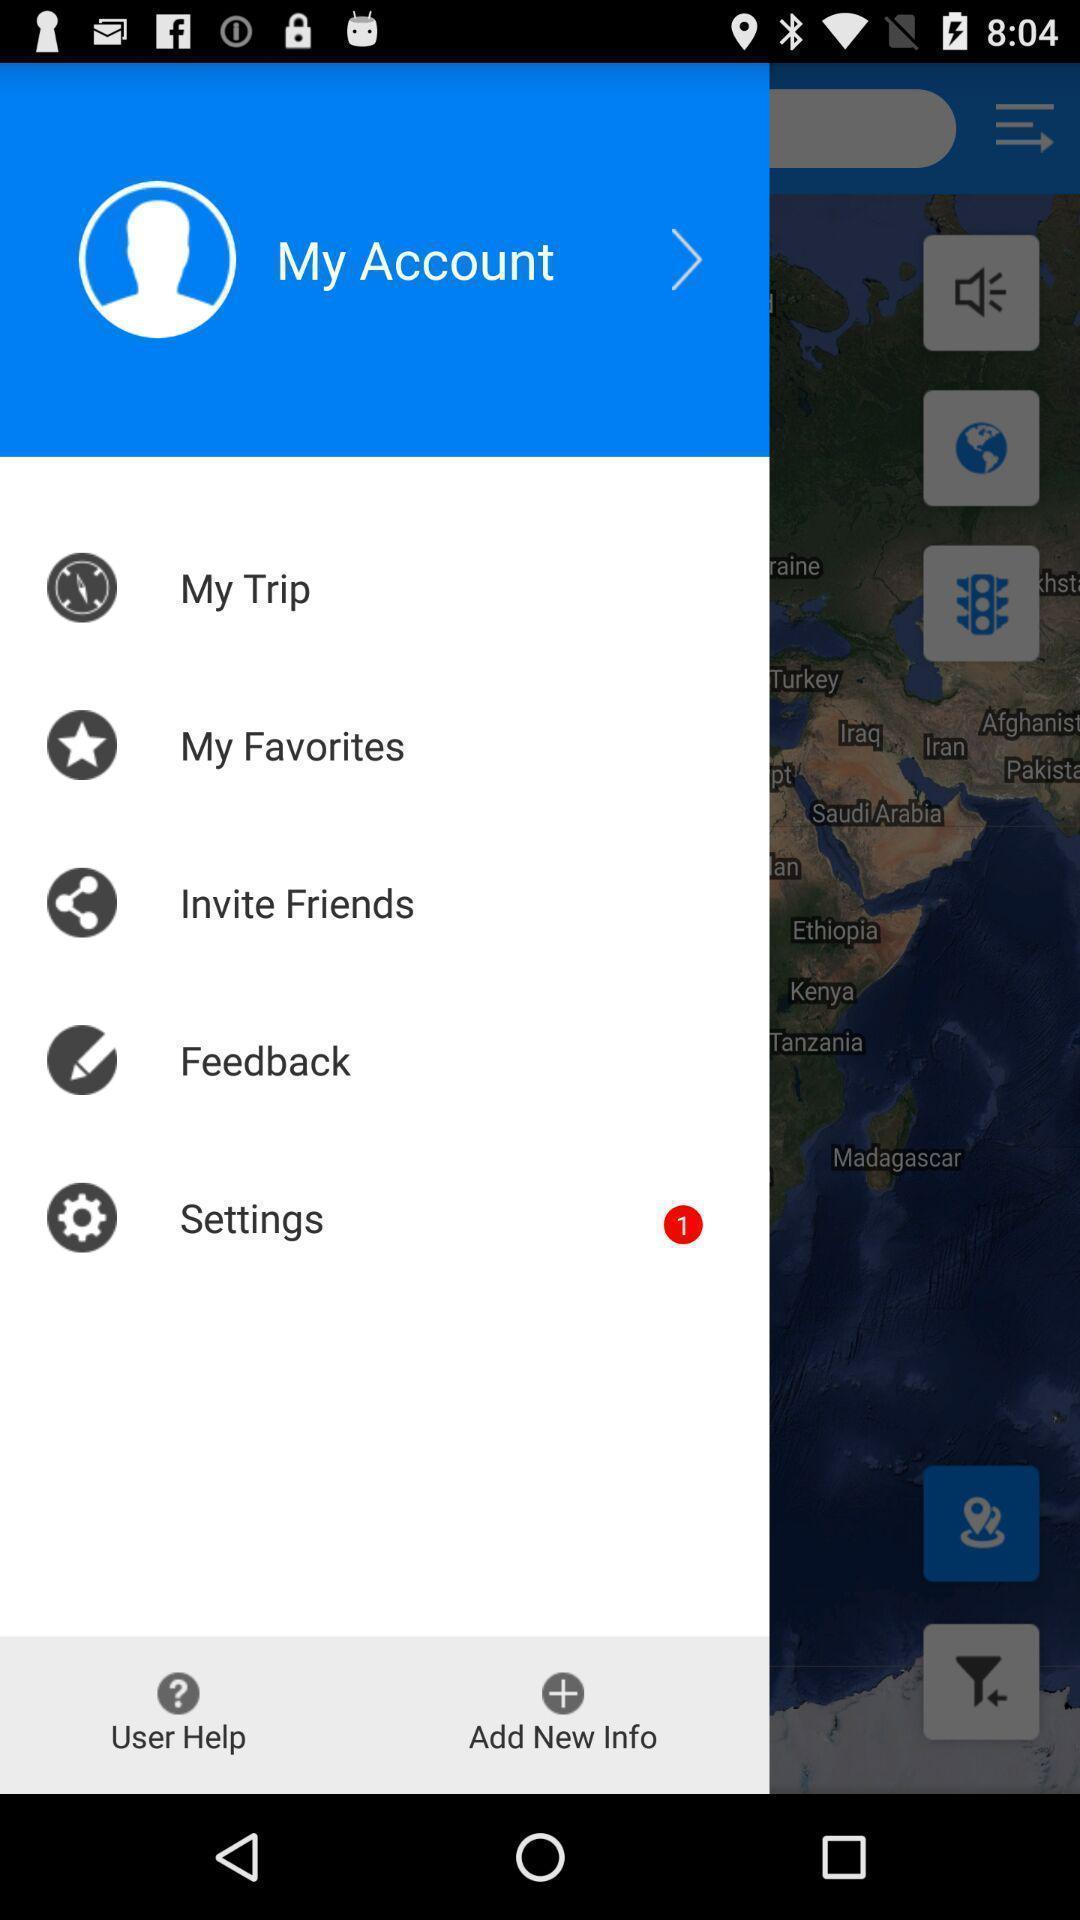Please provide a description for this image. Screen displaying multiple options in account profile. 